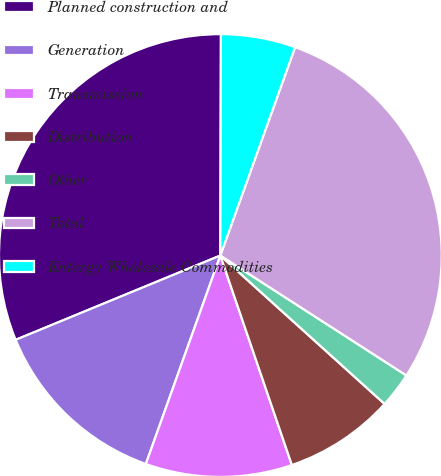Convert chart to OTSL. <chart><loc_0><loc_0><loc_500><loc_500><pie_chart><fcel>Planned construction and<fcel>Generation<fcel>Transmission<fcel>Distribution<fcel>Other<fcel>Total<fcel>Entergy Wholesale Commodities<nl><fcel>31.26%<fcel>13.32%<fcel>10.7%<fcel>8.07%<fcel>2.58%<fcel>28.63%<fcel>5.44%<nl></chart> 